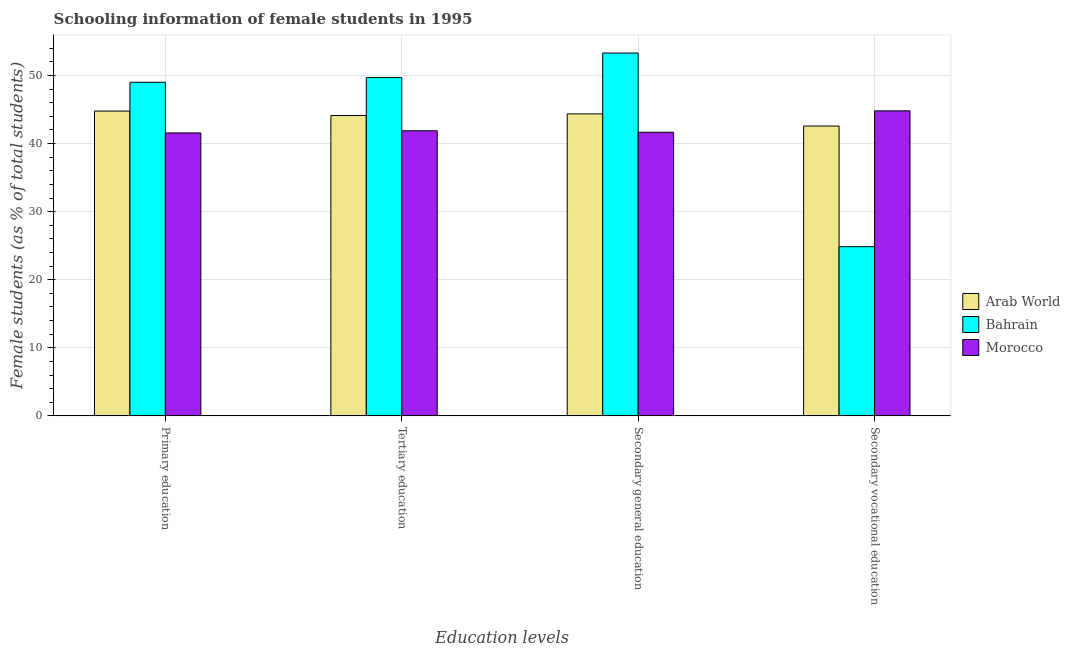What is the label of the 2nd group of bars from the left?
Offer a very short reply. Tertiary education. What is the percentage of female students in tertiary education in Morocco?
Provide a short and direct response. 41.88. Across all countries, what is the maximum percentage of female students in secondary education?
Provide a succinct answer. 53.3. Across all countries, what is the minimum percentage of female students in tertiary education?
Offer a very short reply. 41.88. In which country was the percentage of female students in secondary education maximum?
Give a very brief answer. Bahrain. In which country was the percentage of female students in secondary vocational education minimum?
Give a very brief answer. Bahrain. What is the total percentage of female students in primary education in the graph?
Offer a very short reply. 135.34. What is the difference between the percentage of female students in primary education in Morocco and that in Arab World?
Your answer should be compact. -3.22. What is the difference between the percentage of female students in tertiary education in Morocco and the percentage of female students in primary education in Arab World?
Ensure brevity in your answer.  -2.89. What is the average percentage of female students in primary education per country?
Your answer should be very brief. 45.11. What is the difference between the percentage of female students in secondary education and percentage of female students in tertiary education in Arab World?
Offer a very short reply. 0.24. What is the ratio of the percentage of female students in secondary vocational education in Arab World to that in Bahrain?
Provide a succinct answer. 1.71. Is the percentage of female students in secondary education in Bahrain less than that in Morocco?
Give a very brief answer. No. What is the difference between the highest and the second highest percentage of female students in tertiary education?
Offer a very short reply. 5.57. What is the difference between the highest and the lowest percentage of female students in secondary vocational education?
Make the answer very short. 19.96. Is it the case that in every country, the sum of the percentage of female students in secondary education and percentage of female students in tertiary education is greater than the sum of percentage of female students in primary education and percentage of female students in secondary vocational education?
Your answer should be compact. Yes. What does the 1st bar from the left in Tertiary education represents?
Your answer should be very brief. Arab World. What does the 1st bar from the right in Tertiary education represents?
Provide a succinct answer. Morocco. Is it the case that in every country, the sum of the percentage of female students in primary education and percentage of female students in tertiary education is greater than the percentage of female students in secondary education?
Provide a succinct answer. Yes. Are all the bars in the graph horizontal?
Provide a succinct answer. No. Are the values on the major ticks of Y-axis written in scientific E-notation?
Your response must be concise. No. Does the graph contain any zero values?
Give a very brief answer. No. How many legend labels are there?
Provide a short and direct response. 3. What is the title of the graph?
Ensure brevity in your answer.  Schooling information of female students in 1995. What is the label or title of the X-axis?
Your answer should be very brief. Education levels. What is the label or title of the Y-axis?
Your answer should be compact. Female students (as % of total students). What is the Female students (as % of total students) in Arab World in Primary education?
Keep it short and to the point. 44.78. What is the Female students (as % of total students) of Bahrain in Primary education?
Ensure brevity in your answer.  49.01. What is the Female students (as % of total students) of Morocco in Primary education?
Give a very brief answer. 41.56. What is the Female students (as % of total students) in Arab World in Tertiary education?
Your answer should be compact. 44.12. What is the Female students (as % of total students) in Bahrain in Tertiary education?
Your answer should be very brief. 49.69. What is the Female students (as % of total students) of Morocco in Tertiary education?
Make the answer very short. 41.88. What is the Female students (as % of total students) in Arab World in Secondary general education?
Offer a terse response. 44.36. What is the Female students (as % of total students) in Bahrain in Secondary general education?
Offer a terse response. 53.3. What is the Female students (as % of total students) of Morocco in Secondary general education?
Give a very brief answer. 41.66. What is the Female students (as % of total students) in Arab World in Secondary vocational education?
Give a very brief answer. 42.58. What is the Female students (as % of total students) of Bahrain in Secondary vocational education?
Give a very brief answer. 24.86. What is the Female students (as % of total students) of Morocco in Secondary vocational education?
Ensure brevity in your answer.  44.81. Across all Education levels, what is the maximum Female students (as % of total students) in Arab World?
Provide a short and direct response. 44.78. Across all Education levels, what is the maximum Female students (as % of total students) in Bahrain?
Your response must be concise. 53.3. Across all Education levels, what is the maximum Female students (as % of total students) in Morocco?
Provide a succinct answer. 44.81. Across all Education levels, what is the minimum Female students (as % of total students) of Arab World?
Provide a short and direct response. 42.58. Across all Education levels, what is the minimum Female students (as % of total students) of Bahrain?
Your answer should be compact. 24.86. Across all Education levels, what is the minimum Female students (as % of total students) in Morocco?
Keep it short and to the point. 41.56. What is the total Female students (as % of total students) in Arab World in the graph?
Offer a terse response. 175.84. What is the total Female students (as % of total students) of Bahrain in the graph?
Provide a short and direct response. 176.86. What is the total Female students (as % of total students) in Morocco in the graph?
Provide a succinct answer. 169.92. What is the difference between the Female students (as % of total students) in Arab World in Primary education and that in Tertiary education?
Provide a succinct answer. 0.66. What is the difference between the Female students (as % of total students) in Bahrain in Primary education and that in Tertiary education?
Your response must be concise. -0.69. What is the difference between the Female students (as % of total students) in Morocco in Primary education and that in Tertiary education?
Offer a very short reply. -0.32. What is the difference between the Female students (as % of total students) in Arab World in Primary education and that in Secondary general education?
Provide a succinct answer. 0.41. What is the difference between the Female students (as % of total students) of Bahrain in Primary education and that in Secondary general education?
Keep it short and to the point. -4.3. What is the difference between the Female students (as % of total students) of Morocco in Primary education and that in Secondary general education?
Your answer should be compact. -0.1. What is the difference between the Female students (as % of total students) in Arab World in Primary education and that in Secondary vocational education?
Offer a very short reply. 2.2. What is the difference between the Female students (as % of total students) of Bahrain in Primary education and that in Secondary vocational education?
Ensure brevity in your answer.  24.15. What is the difference between the Female students (as % of total students) in Morocco in Primary education and that in Secondary vocational education?
Your response must be concise. -3.25. What is the difference between the Female students (as % of total students) of Arab World in Tertiary education and that in Secondary general education?
Your answer should be compact. -0.24. What is the difference between the Female students (as % of total students) of Bahrain in Tertiary education and that in Secondary general education?
Give a very brief answer. -3.61. What is the difference between the Female students (as % of total students) of Morocco in Tertiary education and that in Secondary general education?
Make the answer very short. 0.22. What is the difference between the Female students (as % of total students) of Arab World in Tertiary education and that in Secondary vocational education?
Offer a terse response. 1.54. What is the difference between the Female students (as % of total students) of Bahrain in Tertiary education and that in Secondary vocational education?
Offer a terse response. 24.84. What is the difference between the Female students (as % of total students) of Morocco in Tertiary education and that in Secondary vocational education?
Offer a very short reply. -2.93. What is the difference between the Female students (as % of total students) in Arab World in Secondary general education and that in Secondary vocational education?
Offer a terse response. 1.79. What is the difference between the Female students (as % of total students) of Bahrain in Secondary general education and that in Secondary vocational education?
Make the answer very short. 28.45. What is the difference between the Female students (as % of total students) in Morocco in Secondary general education and that in Secondary vocational education?
Provide a succinct answer. -3.15. What is the difference between the Female students (as % of total students) of Arab World in Primary education and the Female students (as % of total students) of Bahrain in Tertiary education?
Keep it short and to the point. -4.92. What is the difference between the Female students (as % of total students) of Arab World in Primary education and the Female students (as % of total students) of Morocco in Tertiary education?
Provide a short and direct response. 2.89. What is the difference between the Female students (as % of total students) in Bahrain in Primary education and the Female students (as % of total students) in Morocco in Tertiary education?
Your answer should be compact. 7.12. What is the difference between the Female students (as % of total students) in Arab World in Primary education and the Female students (as % of total students) in Bahrain in Secondary general education?
Your answer should be compact. -8.53. What is the difference between the Female students (as % of total students) in Arab World in Primary education and the Female students (as % of total students) in Morocco in Secondary general education?
Your answer should be very brief. 3.11. What is the difference between the Female students (as % of total students) in Bahrain in Primary education and the Female students (as % of total students) in Morocco in Secondary general education?
Provide a succinct answer. 7.34. What is the difference between the Female students (as % of total students) of Arab World in Primary education and the Female students (as % of total students) of Bahrain in Secondary vocational education?
Give a very brief answer. 19.92. What is the difference between the Female students (as % of total students) in Arab World in Primary education and the Female students (as % of total students) in Morocco in Secondary vocational education?
Make the answer very short. -0.03. What is the difference between the Female students (as % of total students) in Bahrain in Primary education and the Female students (as % of total students) in Morocco in Secondary vocational education?
Make the answer very short. 4.2. What is the difference between the Female students (as % of total students) in Arab World in Tertiary education and the Female students (as % of total students) in Bahrain in Secondary general education?
Offer a very short reply. -9.18. What is the difference between the Female students (as % of total students) in Arab World in Tertiary education and the Female students (as % of total students) in Morocco in Secondary general education?
Offer a terse response. 2.46. What is the difference between the Female students (as % of total students) of Bahrain in Tertiary education and the Female students (as % of total students) of Morocco in Secondary general education?
Your answer should be very brief. 8.03. What is the difference between the Female students (as % of total students) in Arab World in Tertiary education and the Female students (as % of total students) in Bahrain in Secondary vocational education?
Your answer should be compact. 19.27. What is the difference between the Female students (as % of total students) in Arab World in Tertiary education and the Female students (as % of total students) in Morocco in Secondary vocational education?
Ensure brevity in your answer.  -0.69. What is the difference between the Female students (as % of total students) in Bahrain in Tertiary education and the Female students (as % of total students) in Morocco in Secondary vocational education?
Your answer should be compact. 4.88. What is the difference between the Female students (as % of total students) in Arab World in Secondary general education and the Female students (as % of total students) in Bahrain in Secondary vocational education?
Provide a short and direct response. 19.51. What is the difference between the Female students (as % of total students) in Arab World in Secondary general education and the Female students (as % of total students) in Morocco in Secondary vocational education?
Give a very brief answer. -0.45. What is the difference between the Female students (as % of total students) in Bahrain in Secondary general education and the Female students (as % of total students) in Morocco in Secondary vocational education?
Make the answer very short. 8.49. What is the average Female students (as % of total students) of Arab World per Education levels?
Make the answer very short. 43.96. What is the average Female students (as % of total students) in Bahrain per Education levels?
Keep it short and to the point. 44.22. What is the average Female students (as % of total students) of Morocco per Education levels?
Your response must be concise. 42.48. What is the difference between the Female students (as % of total students) in Arab World and Female students (as % of total students) in Bahrain in Primary education?
Offer a very short reply. -4.23. What is the difference between the Female students (as % of total students) in Arab World and Female students (as % of total students) in Morocco in Primary education?
Offer a terse response. 3.22. What is the difference between the Female students (as % of total students) of Bahrain and Female students (as % of total students) of Morocco in Primary education?
Your answer should be compact. 7.45. What is the difference between the Female students (as % of total students) in Arab World and Female students (as % of total students) in Bahrain in Tertiary education?
Provide a short and direct response. -5.57. What is the difference between the Female students (as % of total students) in Arab World and Female students (as % of total students) in Morocco in Tertiary education?
Provide a succinct answer. 2.24. What is the difference between the Female students (as % of total students) in Bahrain and Female students (as % of total students) in Morocco in Tertiary education?
Make the answer very short. 7.81. What is the difference between the Female students (as % of total students) in Arab World and Female students (as % of total students) in Bahrain in Secondary general education?
Keep it short and to the point. -8.94. What is the difference between the Female students (as % of total students) of Arab World and Female students (as % of total students) of Morocco in Secondary general education?
Keep it short and to the point. 2.7. What is the difference between the Female students (as % of total students) in Bahrain and Female students (as % of total students) in Morocco in Secondary general education?
Make the answer very short. 11.64. What is the difference between the Female students (as % of total students) in Arab World and Female students (as % of total students) in Bahrain in Secondary vocational education?
Your response must be concise. 17.72. What is the difference between the Female students (as % of total students) of Arab World and Female students (as % of total students) of Morocco in Secondary vocational education?
Make the answer very short. -2.23. What is the difference between the Female students (as % of total students) in Bahrain and Female students (as % of total students) in Morocco in Secondary vocational education?
Keep it short and to the point. -19.96. What is the ratio of the Female students (as % of total students) of Arab World in Primary education to that in Tertiary education?
Ensure brevity in your answer.  1.01. What is the ratio of the Female students (as % of total students) of Bahrain in Primary education to that in Tertiary education?
Provide a succinct answer. 0.99. What is the ratio of the Female students (as % of total students) of Morocco in Primary education to that in Tertiary education?
Make the answer very short. 0.99. What is the ratio of the Female students (as % of total students) of Arab World in Primary education to that in Secondary general education?
Your response must be concise. 1.01. What is the ratio of the Female students (as % of total students) in Bahrain in Primary education to that in Secondary general education?
Give a very brief answer. 0.92. What is the ratio of the Female students (as % of total students) of Morocco in Primary education to that in Secondary general education?
Your response must be concise. 1. What is the ratio of the Female students (as % of total students) of Arab World in Primary education to that in Secondary vocational education?
Ensure brevity in your answer.  1.05. What is the ratio of the Female students (as % of total students) of Bahrain in Primary education to that in Secondary vocational education?
Keep it short and to the point. 1.97. What is the ratio of the Female students (as % of total students) in Morocco in Primary education to that in Secondary vocational education?
Offer a very short reply. 0.93. What is the ratio of the Female students (as % of total students) in Arab World in Tertiary education to that in Secondary general education?
Keep it short and to the point. 0.99. What is the ratio of the Female students (as % of total students) in Bahrain in Tertiary education to that in Secondary general education?
Make the answer very short. 0.93. What is the ratio of the Female students (as % of total students) in Morocco in Tertiary education to that in Secondary general education?
Ensure brevity in your answer.  1.01. What is the ratio of the Female students (as % of total students) in Arab World in Tertiary education to that in Secondary vocational education?
Keep it short and to the point. 1.04. What is the ratio of the Female students (as % of total students) of Bahrain in Tertiary education to that in Secondary vocational education?
Offer a terse response. 2. What is the ratio of the Female students (as % of total students) in Morocco in Tertiary education to that in Secondary vocational education?
Your answer should be compact. 0.93. What is the ratio of the Female students (as % of total students) in Arab World in Secondary general education to that in Secondary vocational education?
Make the answer very short. 1.04. What is the ratio of the Female students (as % of total students) in Bahrain in Secondary general education to that in Secondary vocational education?
Make the answer very short. 2.14. What is the ratio of the Female students (as % of total students) of Morocco in Secondary general education to that in Secondary vocational education?
Your answer should be very brief. 0.93. What is the difference between the highest and the second highest Female students (as % of total students) of Arab World?
Keep it short and to the point. 0.41. What is the difference between the highest and the second highest Female students (as % of total students) of Bahrain?
Ensure brevity in your answer.  3.61. What is the difference between the highest and the second highest Female students (as % of total students) in Morocco?
Offer a very short reply. 2.93. What is the difference between the highest and the lowest Female students (as % of total students) in Arab World?
Your response must be concise. 2.2. What is the difference between the highest and the lowest Female students (as % of total students) in Bahrain?
Make the answer very short. 28.45. What is the difference between the highest and the lowest Female students (as % of total students) in Morocco?
Make the answer very short. 3.25. 